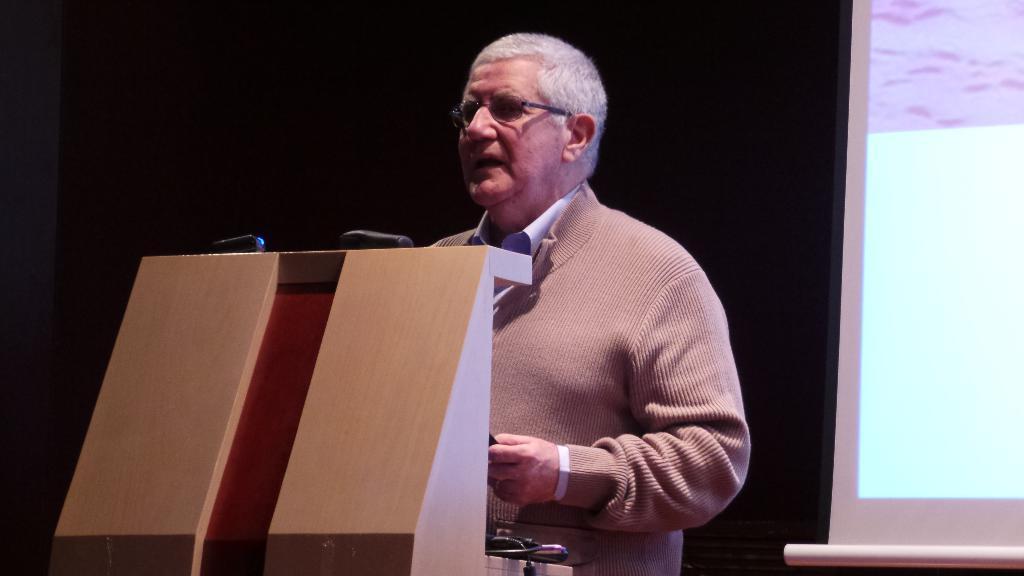Please provide a concise description of this image. In this picture we can see a man wore spectacle and standing at a podium and in the background we can see a screen 